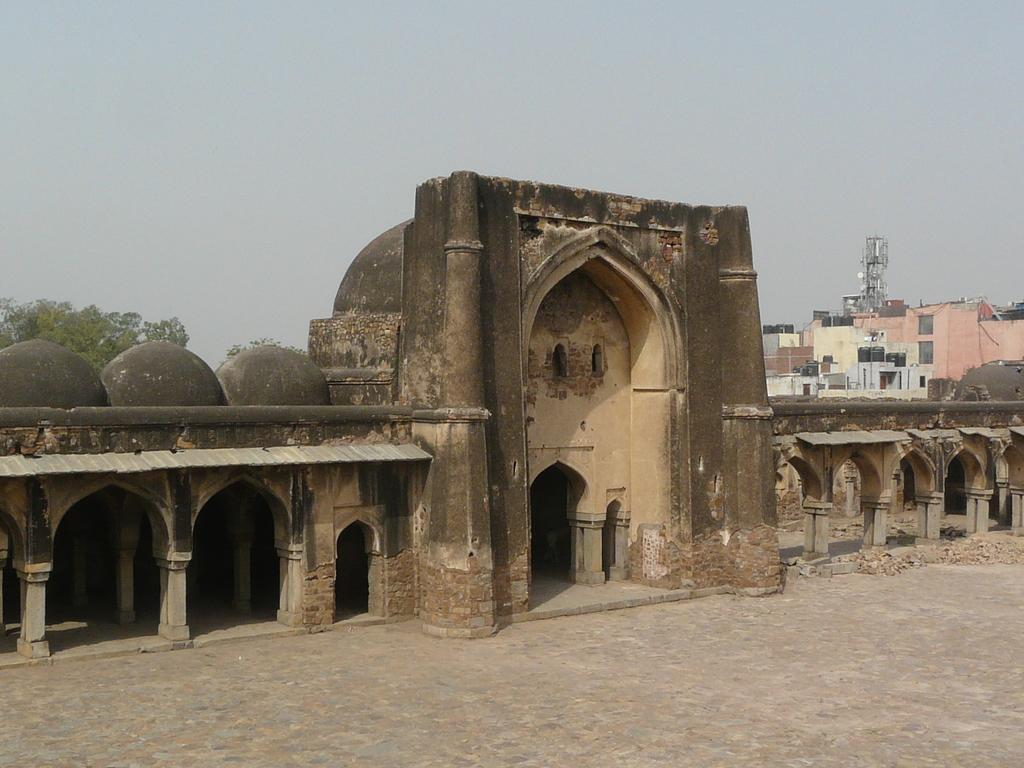What is the main structure in the image? There is a fort in the image. What can be seen in the background of the image? There are buildings, a tower, a tree, and the sky visible in the background of the image. What type of instrument is being played by the deer in the image? There are no deer or instruments present in the image. 